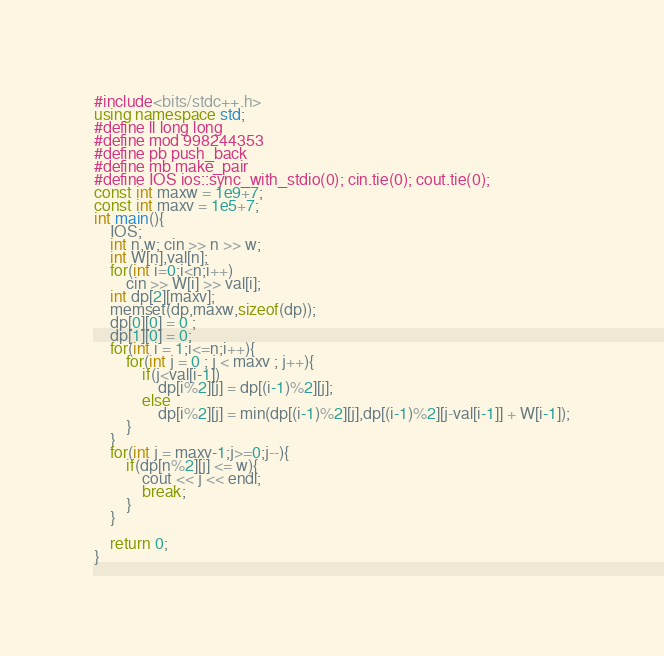<code> <loc_0><loc_0><loc_500><loc_500><_C++_>#include<bits/stdc++.h>
using namespace std;
#define ll long long
#define mod 998244353 
#define pb push_back
#define mb make_pair
#define IOS ios::sync_with_stdio(0); cin.tie(0); cout.tie(0);
const int maxw = 1e9+7;
const int maxv = 1e5+7;
int main(){
	IOS;
	int n,w; cin >> n >> w;
	int W[n],val[n];
	for(int i=0;i<n;i++)
		cin >> W[i] >> val[i];
	int dp[2][maxv];
	memset(dp,maxw,sizeof(dp));
	dp[0][0] = 0 ;
	dp[1][0] = 0; 
	for(int i = 1;i<=n;i++){
		for(int j = 0 ; j < maxv ; j++){
			if(j<val[i-1])
				dp[i%2][j] = dp[(i-1)%2][j];
			else
				dp[i%2][j] = min(dp[(i-1)%2][j],dp[(i-1)%2][j-val[i-1]] + W[i-1]);
		}
	}
	for(int j = maxv-1;j>=0;j--){
		if(dp[n%2][j] <= w){
			cout << j << endl;
			break;
		}
	}

	return 0;
}


</code> 